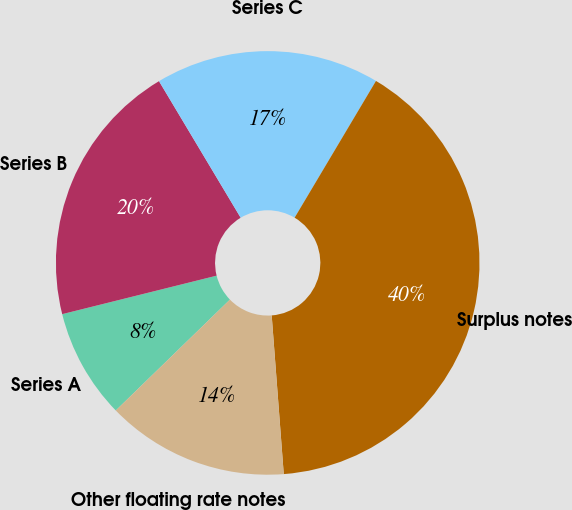Convert chart to OTSL. <chart><loc_0><loc_0><loc_500><loc_500><pie_chart><fcel>Series A<fcel>Series B<fcel>Series C<fcel>Surplus notes<fcel>Other floating rate notes<nl><fcel>8.38%<fcel>20.31%<fcel>17.12%<fcel>40.25%<fcel>13.94%<nl></chart> 